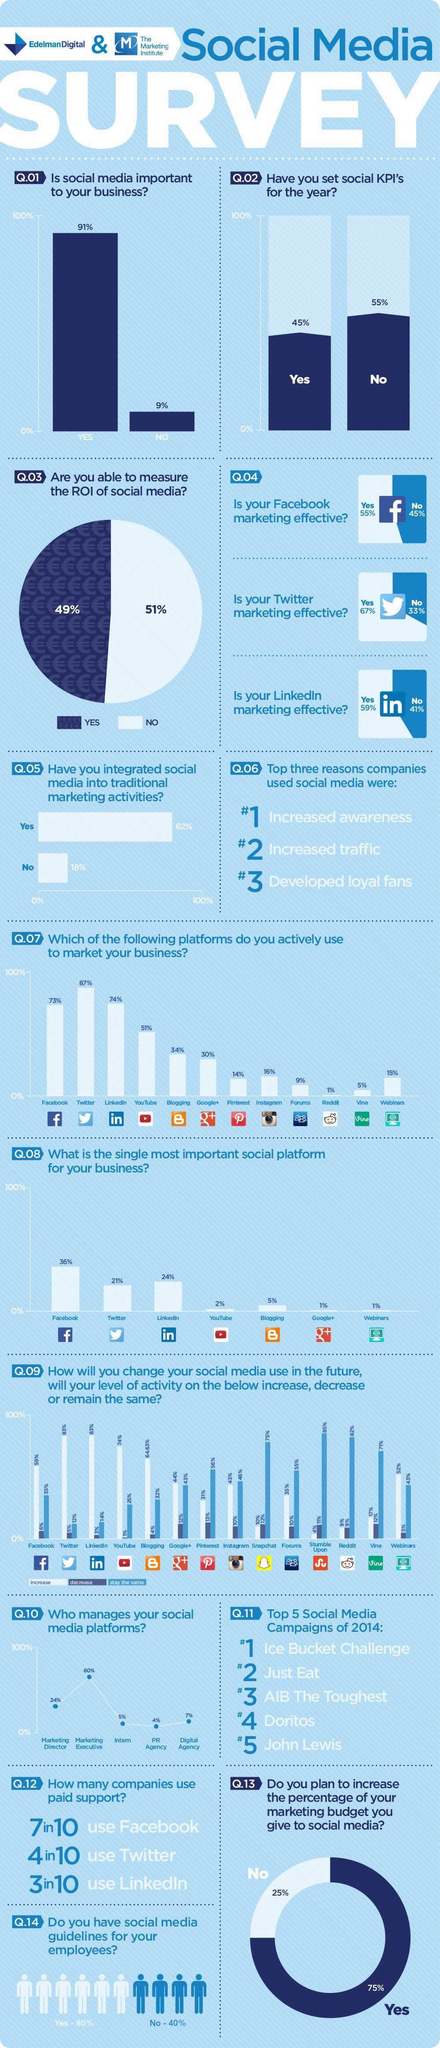Highlight a few significant elements in this photo. The level of activity on YouTube has increased by 74%. The level of activity on Facebook has increased by 59%. The level of activity on Facebook has decreased by 6%. The level of activity among users on Facebook remains relatively constant for approximately 35% of users. The second best platform to use to market your business is LinkedIn. 